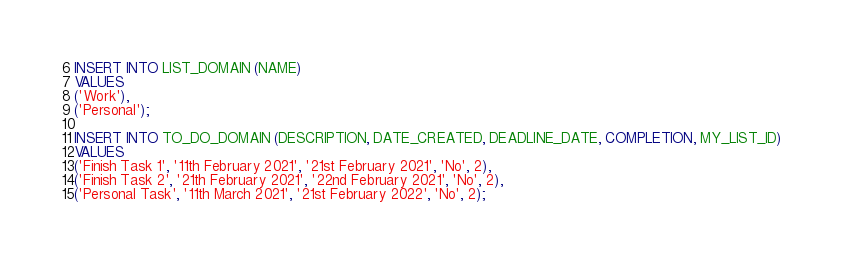<code> <loc_0><loc_0><loc_500><loc_500><_SQL_>INSERT INTO LIST_DOMAIN (NAME) 
VALUES 
('Work'), 
('Personal');

INSERT INTO TO_DO_DOMAIN (DESCRIPTION, DATE_CREATED, DEADLINE_DATE, COMPLETION, MY_LIST_ID) 
VALUES 
('Finish Task 1', '11th February 2021', '21st February 2021', 'No', 2), 
('Finish Task 2', '21th February 2021', '22nd February 2021', 'No', 2), 
('Personal Task', '11th March 2021', '21st February 2022', 'No', 2);</code> 